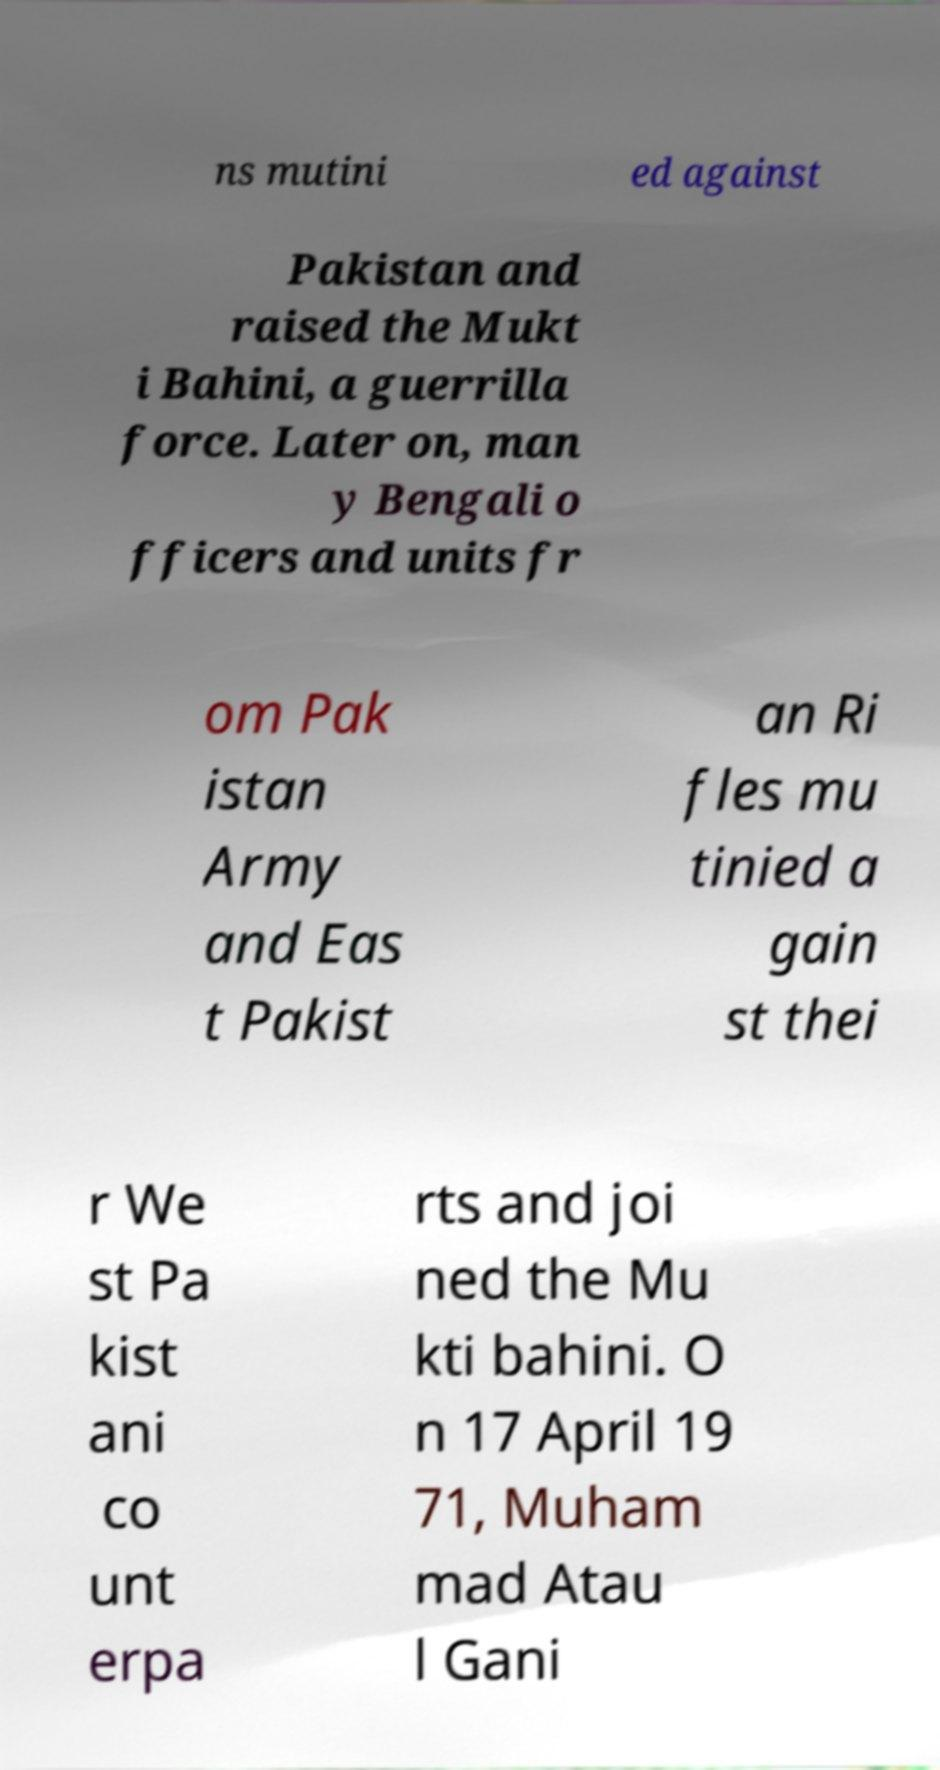Could you assist in decoding the text presented in this image and type it out clearly? ns mutini ed against Pakistan and raised the Mukt i Bahini, a guerrilla force. Later on, man y Bengali o fficers and units fr om Pak istan Army and Eas t Pakist an Ri fles mu tinied a gain st thei r We st Pa kist ani co unt erpa rts and joi ned the Mu kti bahini. O n 17 April 19 71, Muham mad Atau l Gani 